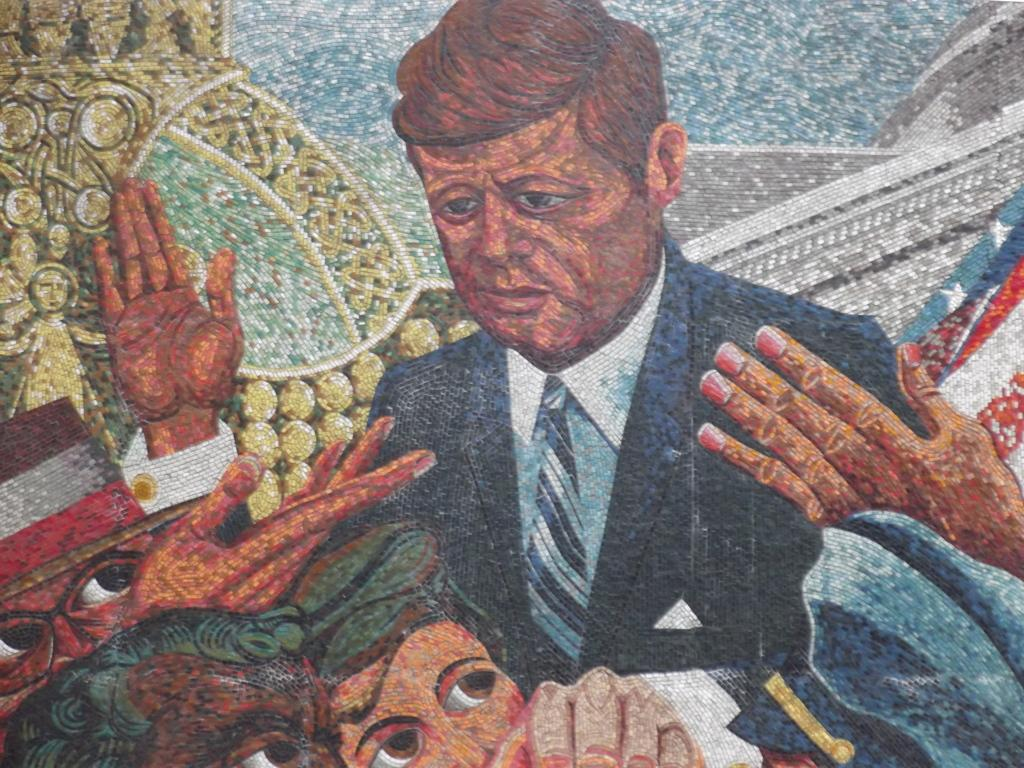What type of screw is being used to teach the coal how to dance in the image? There is no screw, coal, or dancing in the image, as no specific facts were provided. 